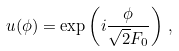<formula> <loc_0><loc_0><loc_500><loc_500>u ( \phi ) = \exp \left ( i \frac { \phi } { \sqrt { 2 } F _ { 0 } } \right ) \, ,</formula> 